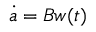Convert formula to latex. <formula><loc_0><loc_0><loc_500><loc_500>\dot { a } = B w ( t )</formula> 